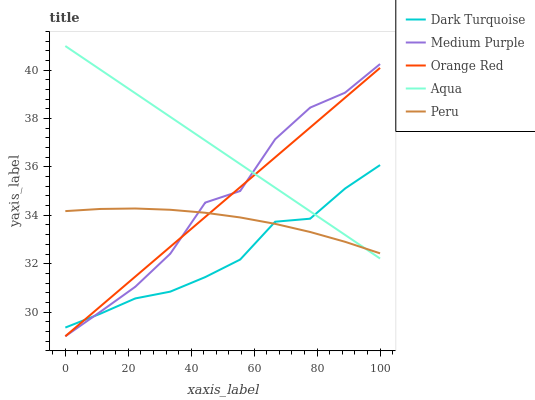Does Dark Turquoise have the minimum area under the curve?
Answer yes or no. Yes. Does Aqua have the maximum area under the curve?
Answer yes or no. Yes. Does Aqua have the minimum area under the curve?
Answer yes or no. No. Does Dark Turquoise have the maximum area under the curve?
Answer yes or no. No. Is Aqua the smoothest?
Answer yes or no. Yes. Is Medium Purple the roughest?
Answer yes or no. Yes. Is Dark Turquoise the smoothest?
Answer yes or no. No. Is Dark Turquoise the roughest?
Answer yes or no. No. Does Medium Purple have the lowest value?
Answer yes or no. Yes. Does Dark Turquoise have the lowest value?
Answer yes or no. No. Does Aqua have the highest value?
Answer yes or no. Yes. Does Dark Turquoise have the highest value?
Answer yes or no. No. Does Orange Red intersect Aqua?
Answer yes or no. Yes. Is Orange Red less than Aqua?
Answer yes or no. No. Is Orange Red greater than Aqua?
Answer yes or no. No. 